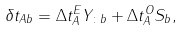<formula> <loc_0><loc_0><loc_500><loc_500>\delta t _ { A b } = \Delta t ^ { E } _ { A } Y _ { \colon b } + \Delta t ^ { O } _ { A } S _ { b } ,</formula> 